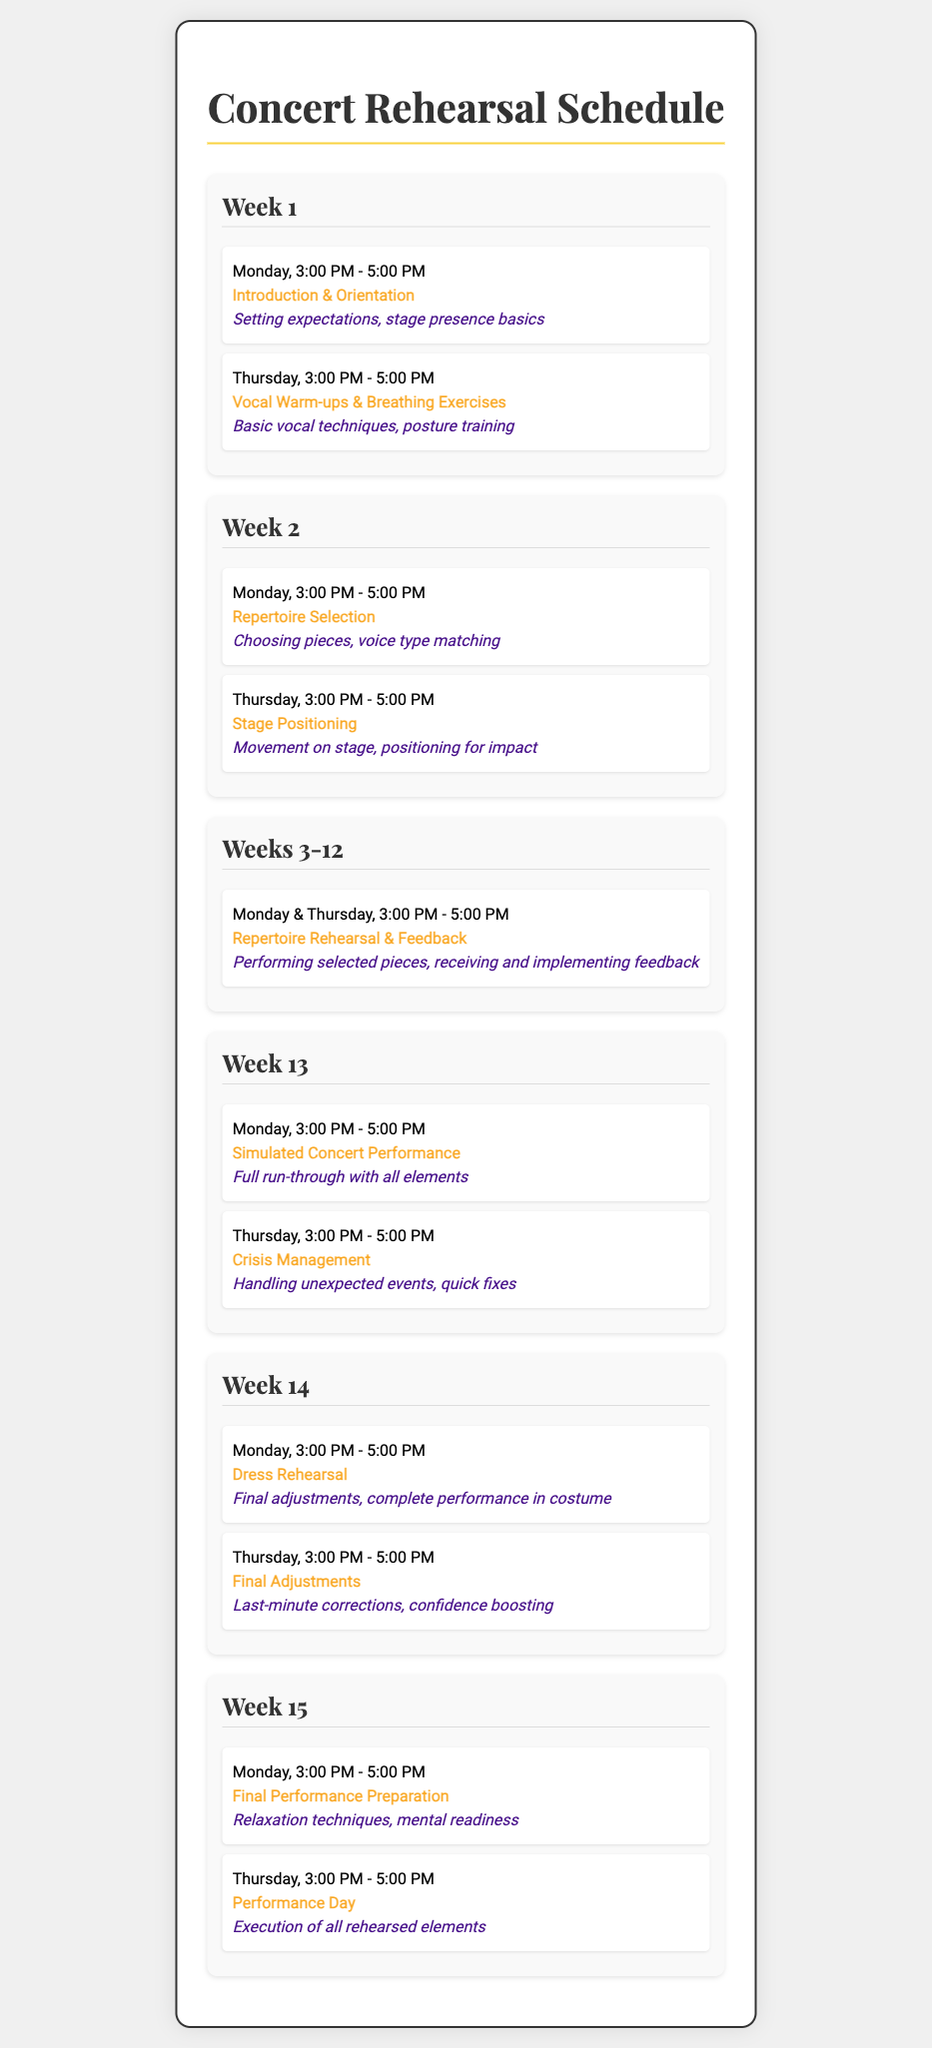What is the title of the document? The title of the document is presented prominently at the top, indicating the content of the schedule.
Answer: Concert Rehearsal Schedule When is the first session of Week 2? The first session is detailed on Monday of Week 2 at the specified time.
Answer: Monday, 3:00 PM - 5:00 PM What is highlighted in Week 1's Thursday session? The focus of this session is clearly labeled as the main activity for that day.
Answer: Vocal Warm-ups & Breathing Exercises How many weeks are dedicated to repertoire rehearsal? The schedule consolidates information regarding these weeks into one section based on the recurring sessions.
Answer: Weeks 3-12 What activity takes place in Week 14 on Monday? The specific session for this day outlines the key practice activity before the final performance.
Answer: Dress Rehearsal What is the focus of the session titled "Crisis Management"? This session addresses a particular topic regarding handling unexpected situations during performances.
Answer: Handling unexpected events, quick fixes 